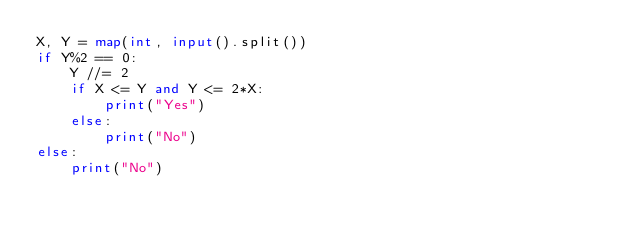Convert code to text. <code><loc_0><loc_0><loc_500><loc_500><_Python_>X, Y = map(int, input().split())
if Y%2 == 0:
    Y //= 2
    if X <= Y and Y <= 2*X:
        print("Yes")
    else:
        print("No")
else:
    print("No")</code> 